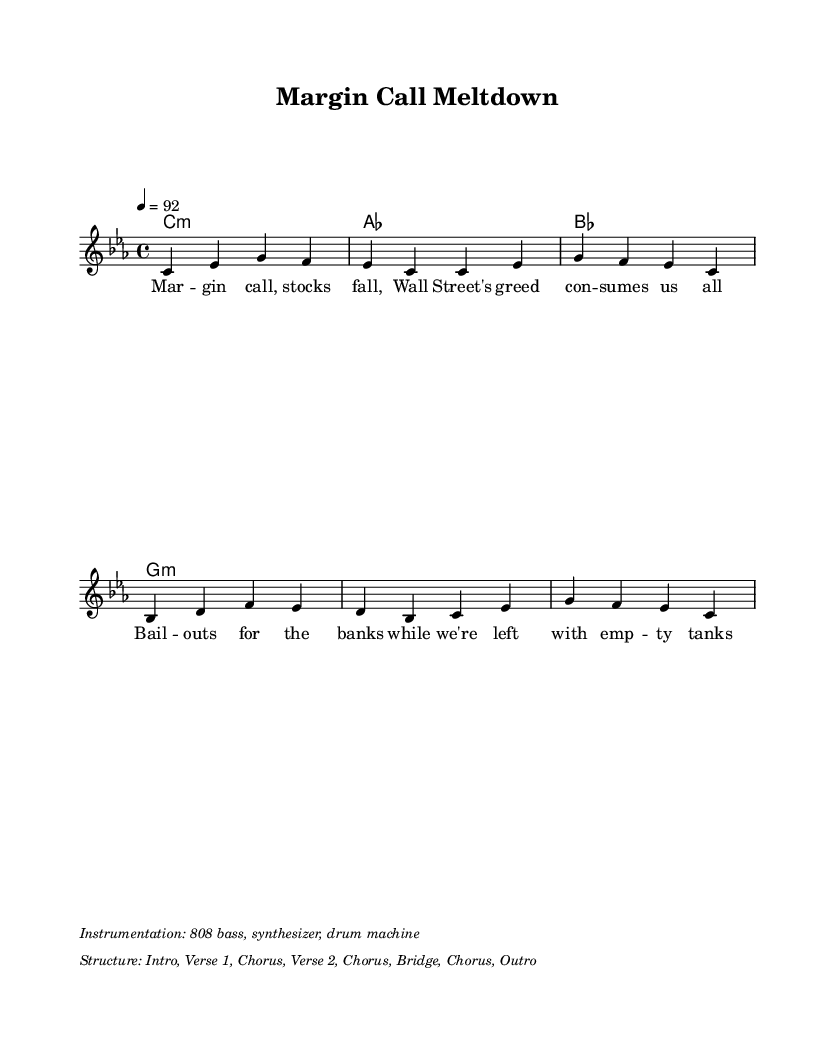What is the key signature of this music? The key signature indicated is C minor, which includes three flats (B, E, and A). This is confirmed by the 'key c \minor' line in the code section, which reflects the tonal center of the piece.
Answer: C minor What is the time signature of this music? The time signature is 4/4, meaning there are four beats in each measure and the quarter note gets one beat. This is typically found in the ' \time 4/4 ' part of the code, which sets the rhythmic framework for the piece.
Answer: 4/4 What is the tempo marking for this music? The tempo marking is indicated as 92 beats per minute. This is specifically noted in the ' \tempo 4 = 92 ' line, which tells musicians how fast to play the piece.
Answer: 92 How many measures are in the melody? The melody consists of four measures, as indicated by the grouping of notes and rests that show where each measure begins and ends. Each of the four sets of note groupings represents one measure.
Answer: 4 What is the main theme of the lyrics? The main theme expresses discontent regarding financial crises and the corruption on Wall Street, emphasizing struggles faced by average people in contrast to bank bailouts. This is derived from the text in the ' \lyricsto "main" ' section, which outlines this social commentary.
Answer: Wall Street corruption Identify the instrumentation mentioned. The instrumentation includes 808 bass, synthesizer, and drum machine, which is specified in the markup section showing what instruments should be used to perform the piece. This informs the style and sound the piece aims to achieve.
Answer: 808 bass, synthesizer, drum machine What is the structure of the music? The structure is outlined as Intro, Verse 1, Chorus, Verse 2, Chorus, Bridge, Chorus, Outro, which is detailed in the markup section and illustrates how the piece is organized in terms of its sections.
Answer: Intro, Verse 1, Chorus, Verse 2, Chorus, Bridge, Chorus, Outro 